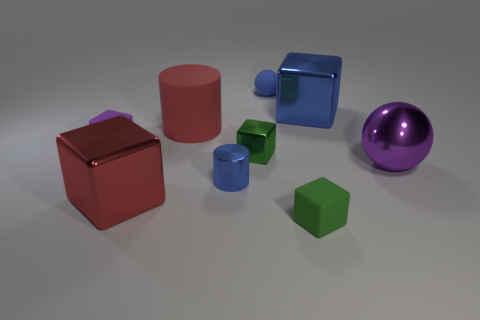There is a object that is the same color as the large shiny sphere; what material is it?
Provide a short and direct response. Rubber. What shape is the purple object behind the purple sphere?
Offer a very short reply. Cube. What number of large red things are there?
Offer a terse response. 2. The cube that is made of the same material as the small purple object is what color?
Offer a terse response. Green. What number of tiny objects are either green cubes or blue shiny objects?
Offer a very short reply. 3. There is a large purple sphere; what number of tiny rubber blocks are in front of it?
Provide a short and direct response. 1. The other small matte thing that is the same shape as the tiny purple thing is what color?
Your answer should be compact. Green. How many matte things are tiny cyan spheres or blue cylinders?
Offer a very short reply. 0. There is a small block in front of the green shiny block on the right side of the blue cylinder; is there a large red matte cylinder in front of it?
Keep it short and to the point. No. What is the color of the big cylinder?
Your response must be concise. Red. 